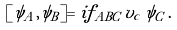<formula> <loc_0><loc_0><loc_500><loc_500>[ \psi _ { A } , \psi _ { B } ] = i f _ { A B C } \, v _ { c } \, \psi _ { C } \, .</formula> 